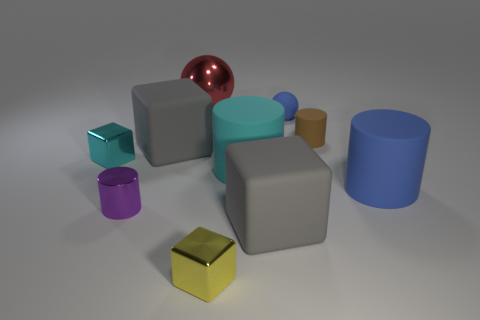Is there anything else that has the same color as the metal cylinder?
Provide a short and direct response. No. Are there fewer yellow metal cubes in front of the small yellow metallic thing than large rubber blocks to the right of the big red sphere?
Offer a very short reply. Yes. What number of gray things are made of the same material as the tiny cyan thing?
Give a very brief answer. 0. There is a big gray rubber cube that is on the right side of the metallic object that is to the right of the big red thing; are there any large matte things behind it?
Offer a very short reply. Yes. How many cylinders are gray rubber things or blue things?
Provide a succinct answer. 1. There is a big blue thing; is its shape the same as the small purple object that is to the left of the cyan matte cylinder?
Provide a succinct answer. Yes. Is the number of small cyan metal cubes to the left of the small cyan shiny thing less than the number of large objects?
Your answer should be compact. Yes. There is a small yellow shiny cube; are there any blue cylinders in front of it?
Your response must be concise. No. Are there any blue matte things of the same shape as the yellow thing?
Provide a succinct answer. No. The cyan rubber object that is the same size as the red sphere is what shape?
Give a very brief answer. Cylinder. 